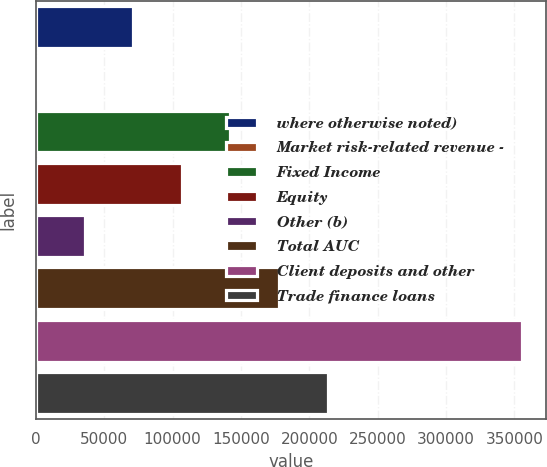<chart> <loc_0><loc_0><loc_500><loc_500><bar_chart><fcel>where otherwise noted)<fcel>Market risk-related revenue -<fcel>Fixed Income<fcel>Equity<fcel>Other (b)<fcel>Total AUC<fcel>Client deposits and other<fcel>Trade finance loans<nl><fcel>71158.8<fcel>7<fcel>142311<fcel>106735<fcel>35582.9<fcel>177886<fcel>355766<fcel>213462<nl></chart> 